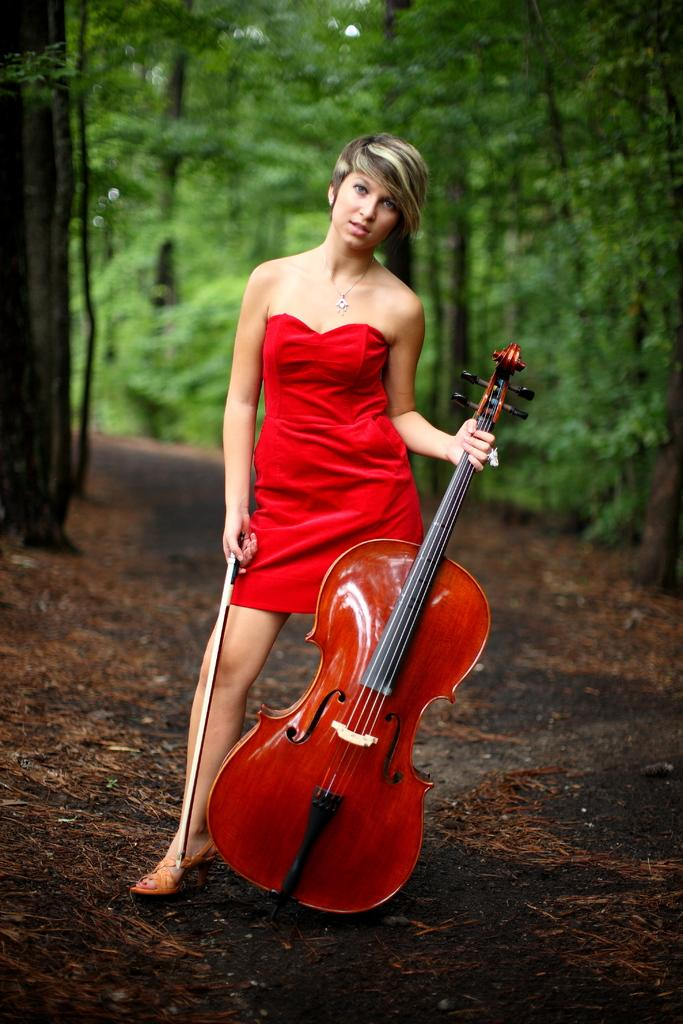What is the main subject of the image? The main subject of the image is a woman. What is the woman doing in the image? The woman is standing and holding a musical instrument. What is the woman wearing in the image? The woman is wearing a red dress. What can be seen in the background of the image? There are trees in the background of the image. What type of lock can be seen on the woman's tooth in the image? There is no lock or tooth present on the woman in the image; she is simply holding a musical instrument and wearing a red dress. 